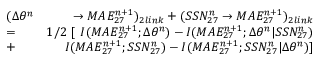Convert formula to latex. <formula><loc_0><loc_0><loc_500><loc_500>\begin{array} { r l r } & { ( \Delta \theta ^ { n } } & { \rightarrow M A E _ { 2 7 } ^ { n + 1 } ) _ { 2 l i n k } + ( S S N _ { 2 7 } ^ { n } \rightarrow M A E _ { 2 7 } ^ { n + 1 } ) _ { 2 l i n k } } \\ & { = } & { 1 / 2 \ [ \ I ( M A E _ { 2 7 } ^ { n + 1 } ; \Delta \theta ^ { n } ) - I ( M A E _ { 2 7 } ^ { n + 1 } ; \Delta \theta ^ { n } | S S N _ { 2 7 } ^ { n } ) } \\ & { + } & { I ( M A E _ { 2 7 } ^ { n + 1 } ; S S N _ { 2 7 } ^ { n } ) - I ( M A E _ { 2 7 } ^ { n + 1 } ; S S N _ { 2 7 } ^ { n } | \Delta \theta ^ { n } ) ] } \end{array}</formula> 